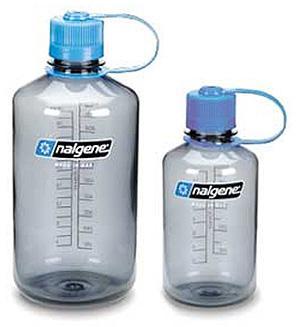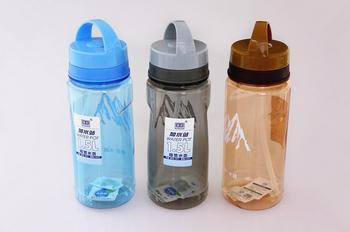The first image is the image on the left, the second image is the image on the right. Given the left and right images, does the statement "The right image contains exactly three bottle containers arranged in a horizontal row." hold true? Answer yes or no. Yes. The first image is the image on the left, the second image is the image on the right. Analyze the images presented: Is the assertion "The left image includes two different-sized water bottles with blue caps that feature a side loop." valid? Answer yes or no. Yes. 